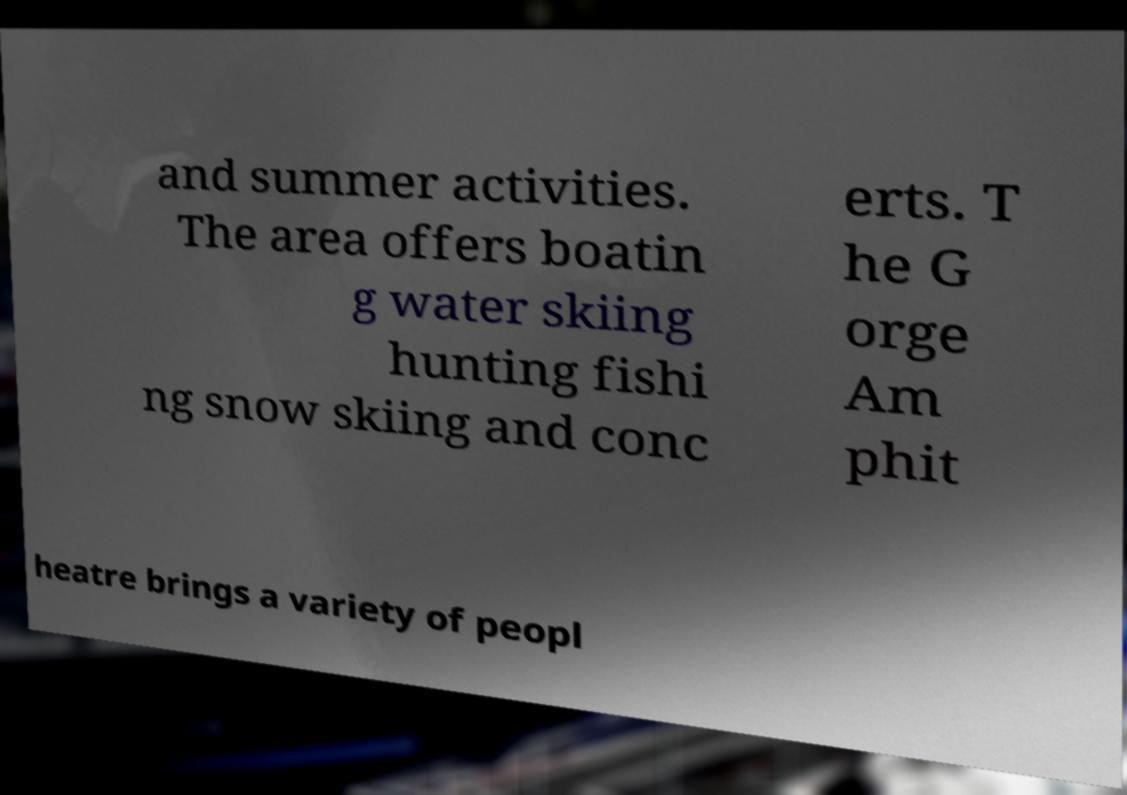Can you read and provide the text displayed in the image?This photo seems to have some interesting text. Can you extract and type it out for me? and summer activities. The area offers boatin g water skiing hunting fishi ng snow skiing and conc erts. T he G orge Am phit heatre brings a variety of peopl 